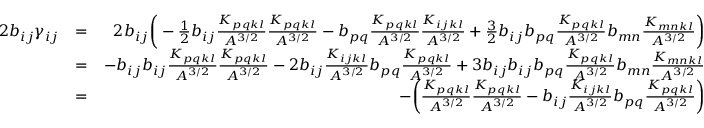<formula> <loc_0><loc_0><loc_500><loc_500>\begin{array} { r l r } { 2 b _ { i j } \gamma _ { i j } } & { = } & { 2 b _ { i j } \left ( - \frac { 1 } { 2 } b _ { i j } \frac { K _ { p q k l } } { A ^ { 3 / 2 } } \frac { K _ { p q k l } } { A ^ { 3 / 2 } } - b _ { p q } \frac { K _ { p q k l } } { A ^ { 3 / 2 } } \frac { K _ { i j k l } } { A ^ { 3 / 2 } } + \frac { 3 } { 2 } b _ { i j } b _ { p q } \frac { K _ { p q k l } } { A ^ { 3 / 2 } } b _ { m n } \frac { K _ { m n k l } } { A ^ { 3 / 2 } } \right ) } \\ & { = } & { - b _ { i j } b _ { i j } \frac { K _ { p q k l } } { A ^ { 3 / 2 } } \frac { K _ { p q k l } } { A ^ { 3 / 2 } } - 2 b _ { i j } \frac { K _ { i j k l } } { A ^ { 3 / 2 } } b _ { p q } \frac { K _ { p q k l } } { A ^ { 3 / 2 } } + 3 b _ { i j } b _ { i j } b _ { p q } \frac { K _ { p q k l } } { A ^ { 3 / 2 } } b _ { m n } \frac { K _ { m n k l } } { A ^ { 3 / 2 } } } \\ & { = } & { - \left ( \frac { K _ { p q k l } } { A ^ { 3 / 2 } } \frac { K _ { p q k l } } { A ^ { 3 / 2 } } - b _ { i j } \frac { K _ { i j k l } } { A ^ { 3 / 2 } } b _ { p q } \frac { K _ { p q k l } } { A ^ { 3 / 2 } } \right ) } \end{array}</formula> 